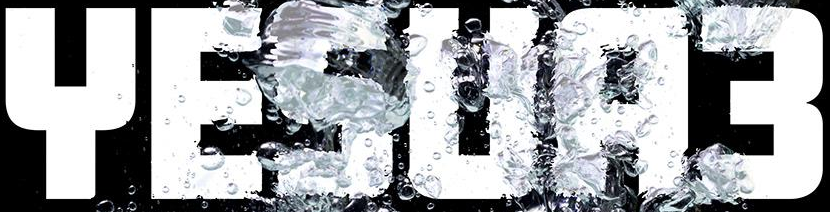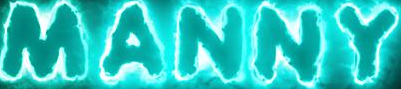What words can you see in these images in sequence, separated by a semicolon? YESUA3; MANNY 